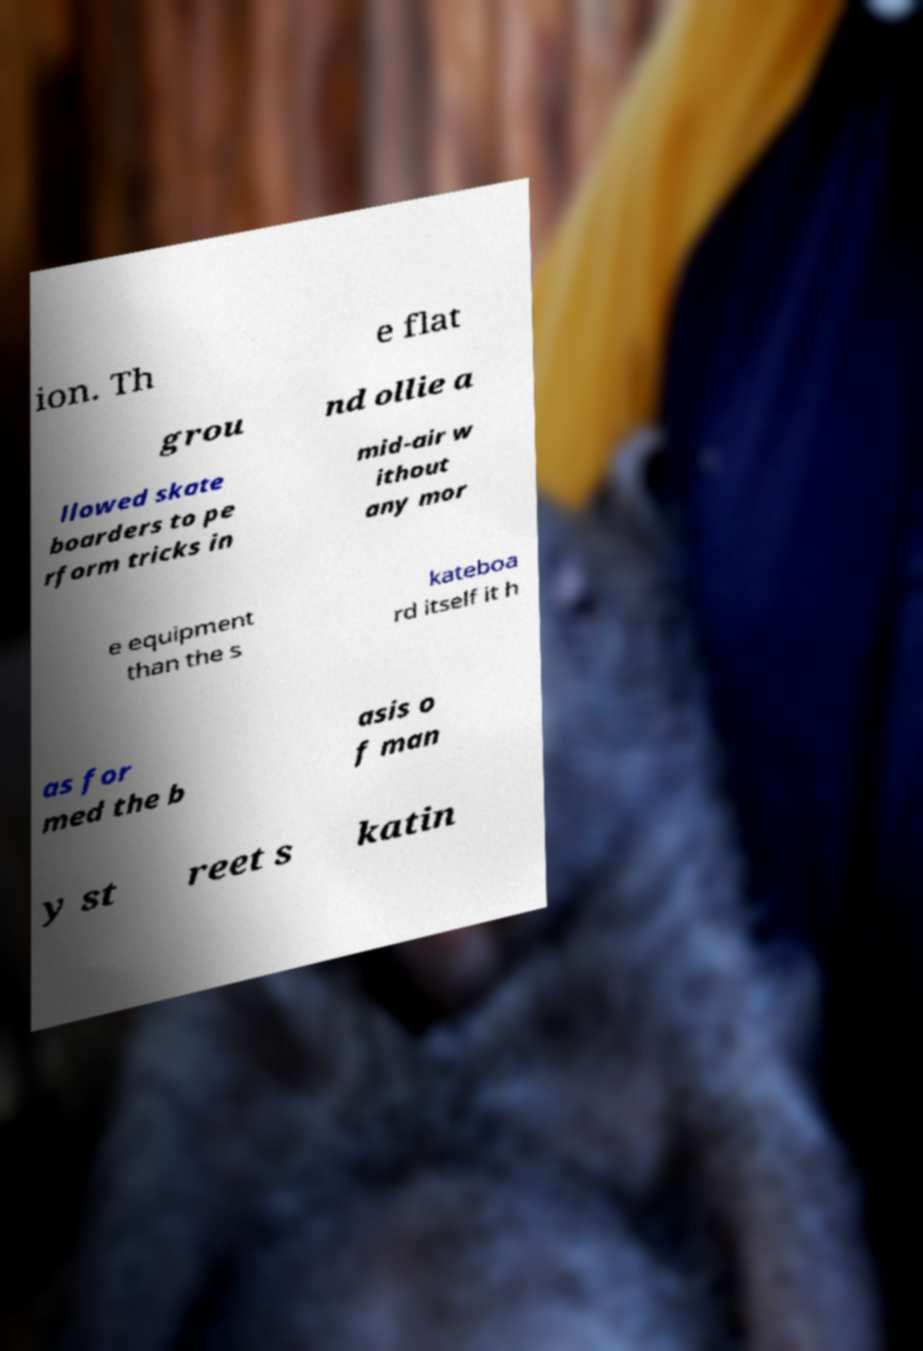For documentation purposes, I need the text within this image transcribed. Could you provide that? ion. Th e flat grou nd ollie a llowed skate boarders to pe rform tricks in mid-air w ithout any mor e equipment than the s kateboa rd itself it h as for med the b asis o f man y st reet s katin 